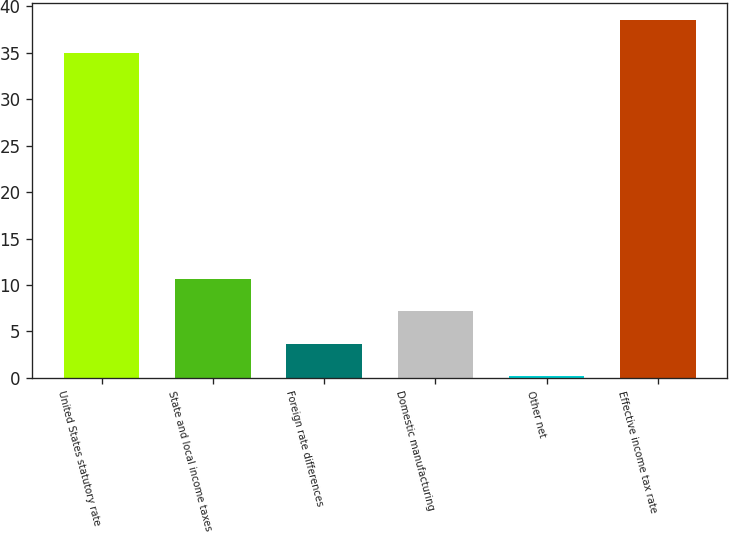Convert chart to OTSL. <chart><loc_0><loc_0><loc_500><loc_500><bar_chart><fcel>United States statutory rate<fcel>State and local income taxes<fcel>Foreign rate differences<fcel>Domestic manufacturing<fcel>Other net<fcel>Effective income tax rate<nl><fcel>35<fcel>10.64<fcel>3.68<fcel>7.16<fcel>0.2<fcel>38.48<nl></chart> 